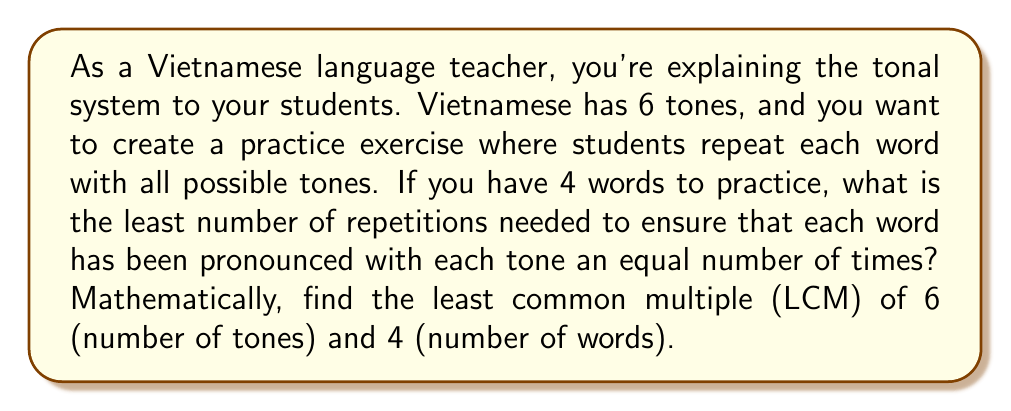What is the answer to this math problem? To solve this problem, we need to find the least common multiple (LCM) of 6 and 4. Let's approach this step-by-step:

1) First, let's find the prime factorization of both numbers:

   $6 = 2 \times 3$
   $4 = 2^2$

2) The LCM will include the highest power of each prime factor from either number. In this case:

   - For 2: We need $2^2$ (from 4)
   - For 3: We need 3 (from 6)

3) Therefore, the LCM is:

   $LCM(6,4) = 2^2 \times 3$

4) Let's calculate this:

   $LCM(6,4) = 4 \times 3 = 12$

This means that after 12 repetitions, each word will have been pronounced with each tone exactly twice:

$\frac{12 \text{ repetitions}}{4 \text{ words}} = 3 \text{ repetitions per word}$
$\frac{12 \text{ repetitions}}{6 \text{ tones}} = 2 \text{ repetitions per tone}$

Thus, 12 is the least number of repetitions needed to ensure each word has been pronounced with each tone an equal number of times.
Answer: $LCM(6,4) = 12$ 